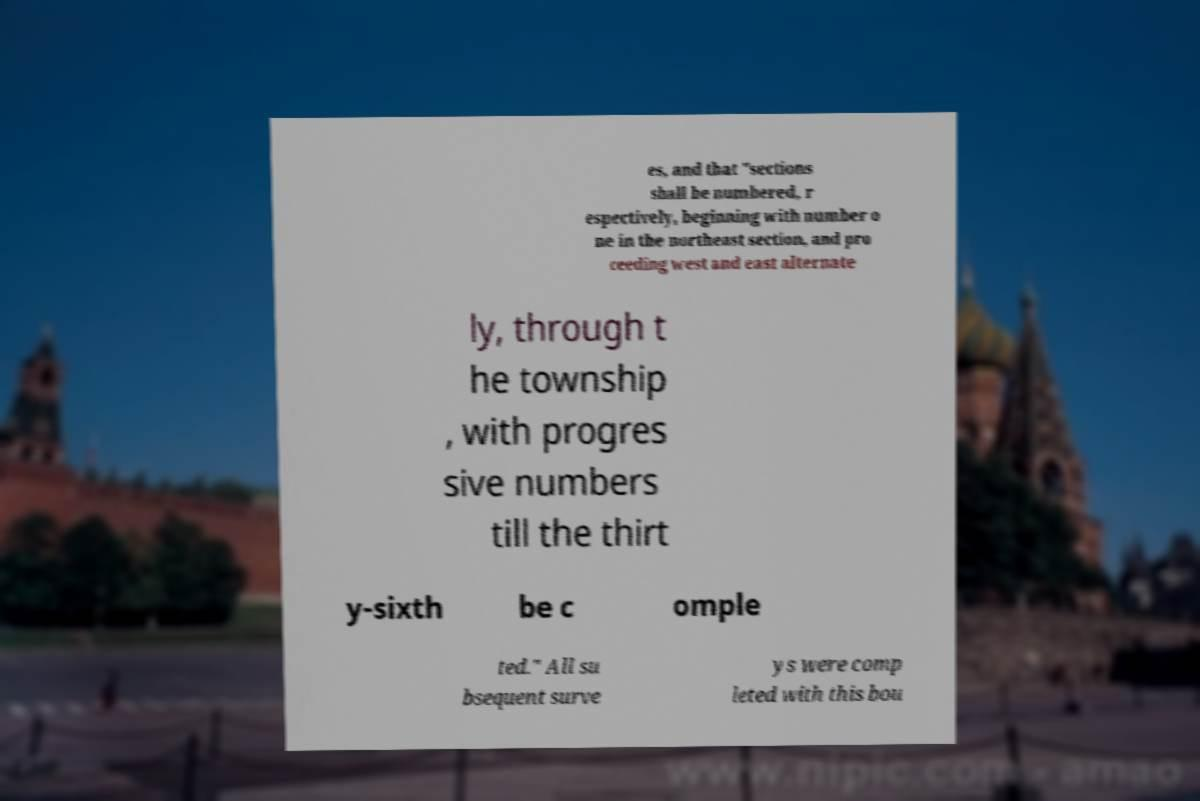I need the written content from this picture converted into text. Can you do that? es, and that "sections shall be numbered, r espectively, beginning with number o ne in the northeast section, and pro ceeding west and east alternate ly, through t he township , with progres sive numbers till the thirt y-sixth be c omple ted." All su bsequent surve ys were comp leted with this bou 